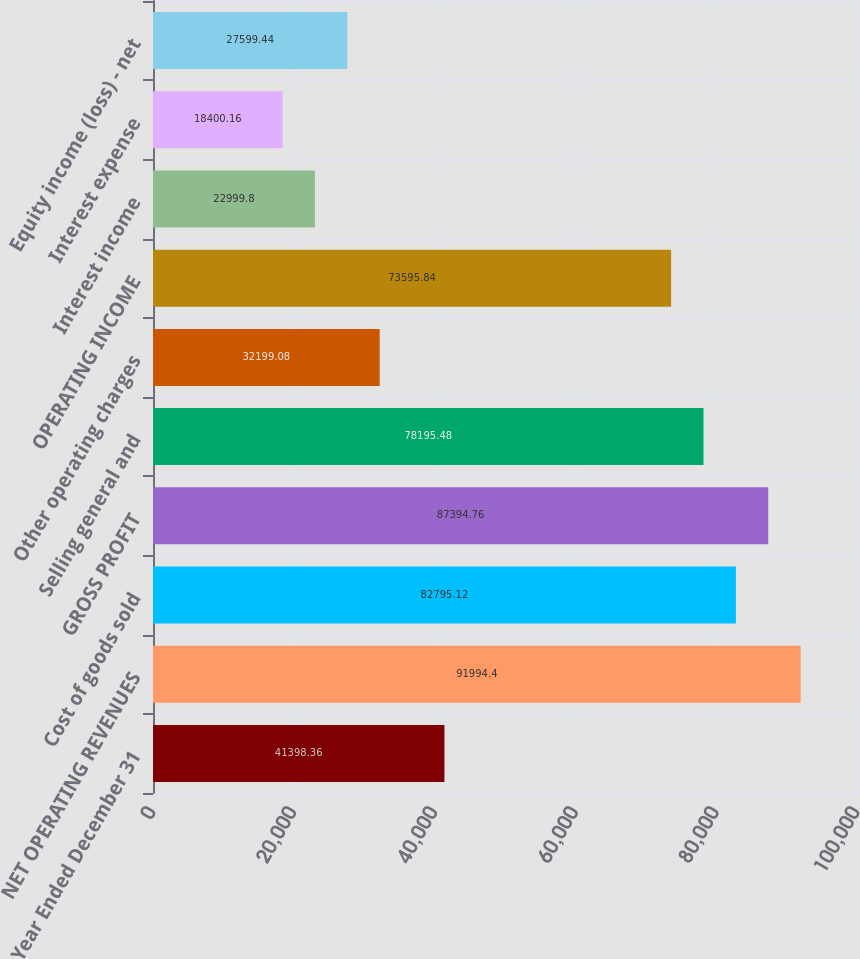Convert chart to OTSL. <chart><loc_0><loc_0><loc_500><loc_500><bar_chart><fcel>Year Ended December 31<fcel>NET OPERATING REVENUES<fcel>Cost of goods sold<fcel>GROSS PROFIT<fcel>Selling general and<fcel>Other operating charges<fcel>OPERATING INCOME<fcel>Interest income<fcel>Interest expense<fcel>Equity income (loss) - net<nl><fcel>41398.4<fcel>91994.4<fcel>82795.1<fcel>87394.8<fcel>78195.5<fcel>32199.1<fcel>73595.8<fcel>22999.8<fcel>18400.2<fcel>27599.4<nl></chart> 